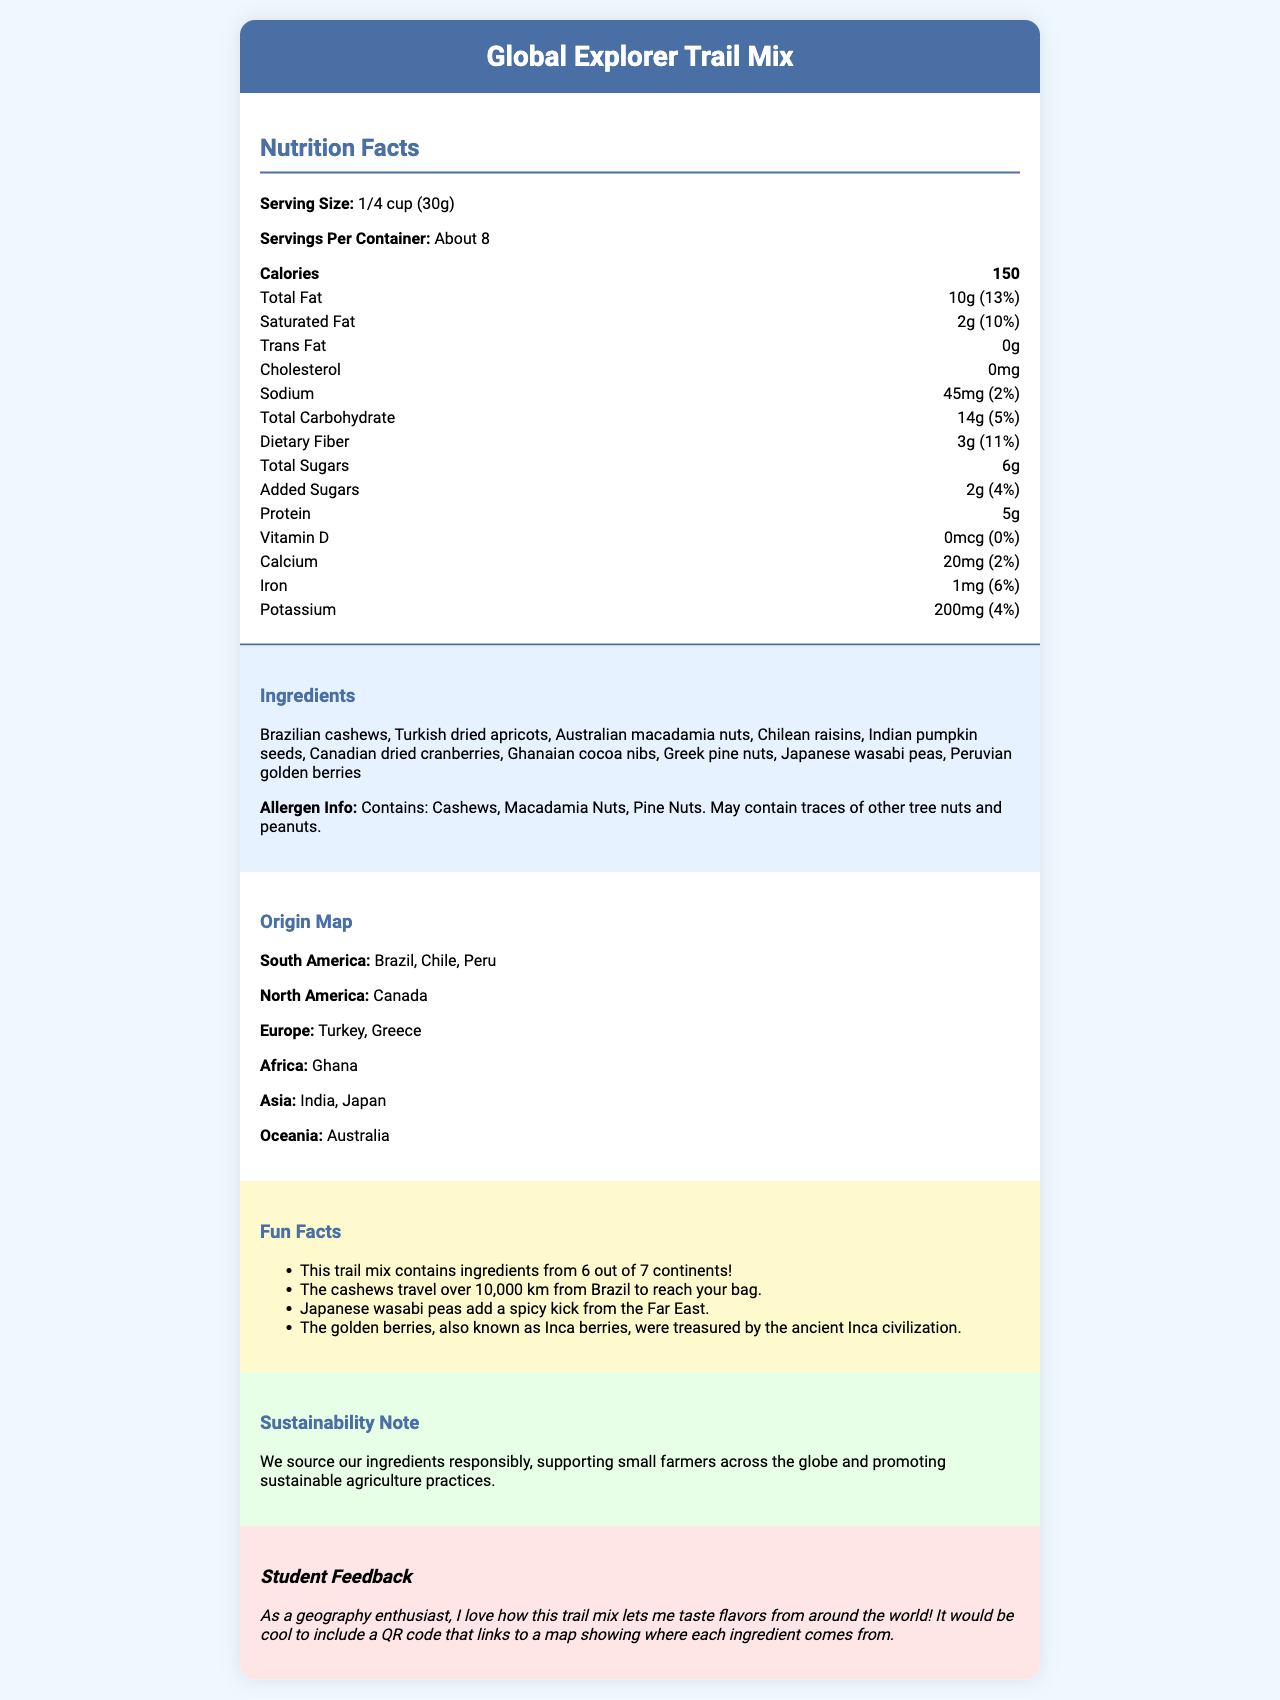what is the serving size? The serving size is explicitly stated as 1/4 cup (30g) in the document.
Answer: 1/4 cup (30g) how many servings are in one container? The document specifies that there are "About 8" servings per container.
Answer: About 8 what is the total fat content per serving? The total fat content per serving is clearly listed as 10g.
Answer: 10g what percentage of the daily value of iron does one serving provide? The document mentions that one serving provides 6% of the daily value of iron.
Answer: 6% how much protein is in each serving? Each serving contains 5g of protein, as stated in the document.
Answer: 5g how many continents are represented in the ingredients of this trail mix? The fun facts note that ingredients are sourced from 6 out of 7 continents.
Answer: 6 which ingredient comes from Brazil? The origin map states that Brazilian cashews are one of the ingredients.
Answer: Cashews does this product contain any cholesterol? The nutrition facts section lists cholesterol as 0mg, so the product does not contain any cholesterol.
Answer: No what's the main idea of the document? The main idea of the document is to inform about the nutritional value, international sourcing of ingredients, and sustainability practices associated with the Global Explorer Trail Mix.
Answer: The document provides detailed nutrition facts, ingredients, origins, and sustainability notes for the Global Explorer Trail Mix. what is the source country of the golden berries? According to the ingredients list, the golden berries are sourced from Peru.
Answer: Peru which ingredient adds a spicy kick according to the fun facts section? A. Cranberries B. Wasabi peas C. Cocoa nibs D. Golden berries The fun facts section mentions that Japanese wasabi peas add a spicy kick from the Far East.
Answer: B. Wasabi peas what is the daily value percentage for saturated fat per serving? A. 10% B. 20% C. 5% D. 0% The document states that the saturated fat content is 2g, which is 10% of the daily value.
Answer: A. 10% does this product contain any added sugars? The nutrition facts section lists added sugars as 2g and 4% of the daily value, indicating that the product contains added sugars.
Answer: Yes are the ingredients in the trail mix sourced responsibly? The sustainability note mentions that the ingredients are sourced responsibly, supporting small farmers and promoting sustainable agriculture practices.
Answer: Yes how many grams of dietary fiber does one serving provide? The document specifies that each serving provides 3g of dietary fiber.
Answer: 3g how many ingredients does this trail mix have? The ingredients list includes 10 different items.
Answer: 10 is there any vitamin D in this trail mix? The nutrition facts section shows that the amount of vitamin D is 0mcg with a 0% daily value, so the trail mix does not contain vitamin D.
Answer: No how much calcium does one serving contain? The document notes that one serving contains 20mg of calcium.
Answer: 20mg why might the ancient Inca civilization have valued the golden berries? According to the fun facts section, golden berries, also known as Inca berries, were valued by the ancient Inca civilization.
Answer: They were known as Inca berries and treasured by the ancient Inca civilization. which continent is not represented in the ingredient list of this trail mix? The fun facts highlight that the trail mix contains ingredients from 6 out of 7 continents, with Antarctica not being represented.
Answer: Antarctica what's the distance traveled by the cashews from Brazil to reach the bag? The fun facts section states that the cashews travel over 10,000 km from Brazil to reach the bag.
Answer: Over 10,000 km what is the total carbohydrate content per serving? The total carbohydrate content per serving is listed as 14g in the nutrition facts section.
Answer: 14g how much sodium does one serving of this trail mix contain? One serving contains 45mg of sodium, according to the document.
Answer: 45mg can we know the price of the Global Explorer Trail Mix from the document? The document does not provide any information regarding the price of the trail mix.
Answer: Cannot be determined 